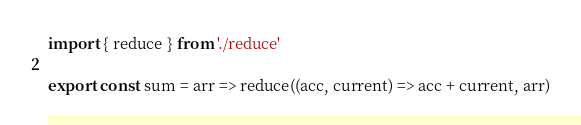Convert code to text. <code><loc_0><loc_0><loc_500><loc_500><_JavaScript_>import { reduce } from './reduce'

export const sum = arr => reduce((acc, current) => acc + current, arr)
</code> 